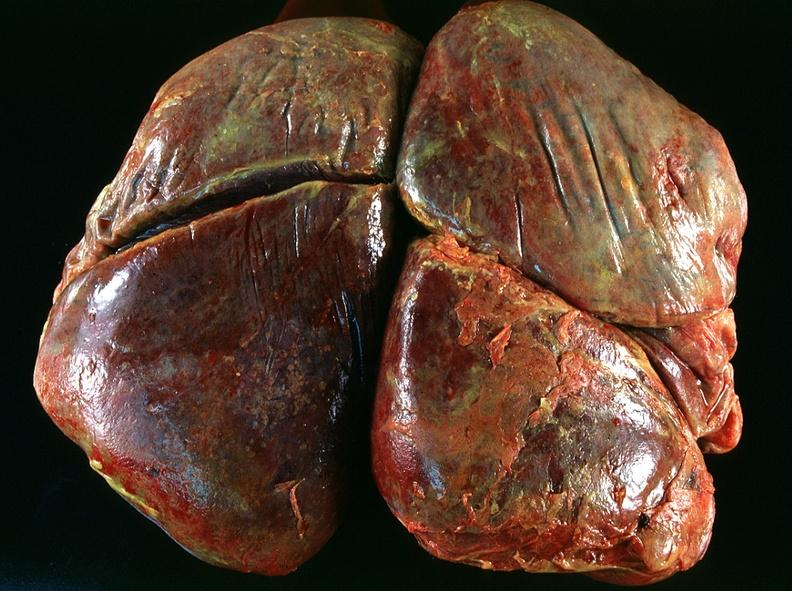does fixed tissue show lung, emphysema and pneumonia, alpha-1 antitrypsin deficiency?
Answer the question using a single word or phrase. No 